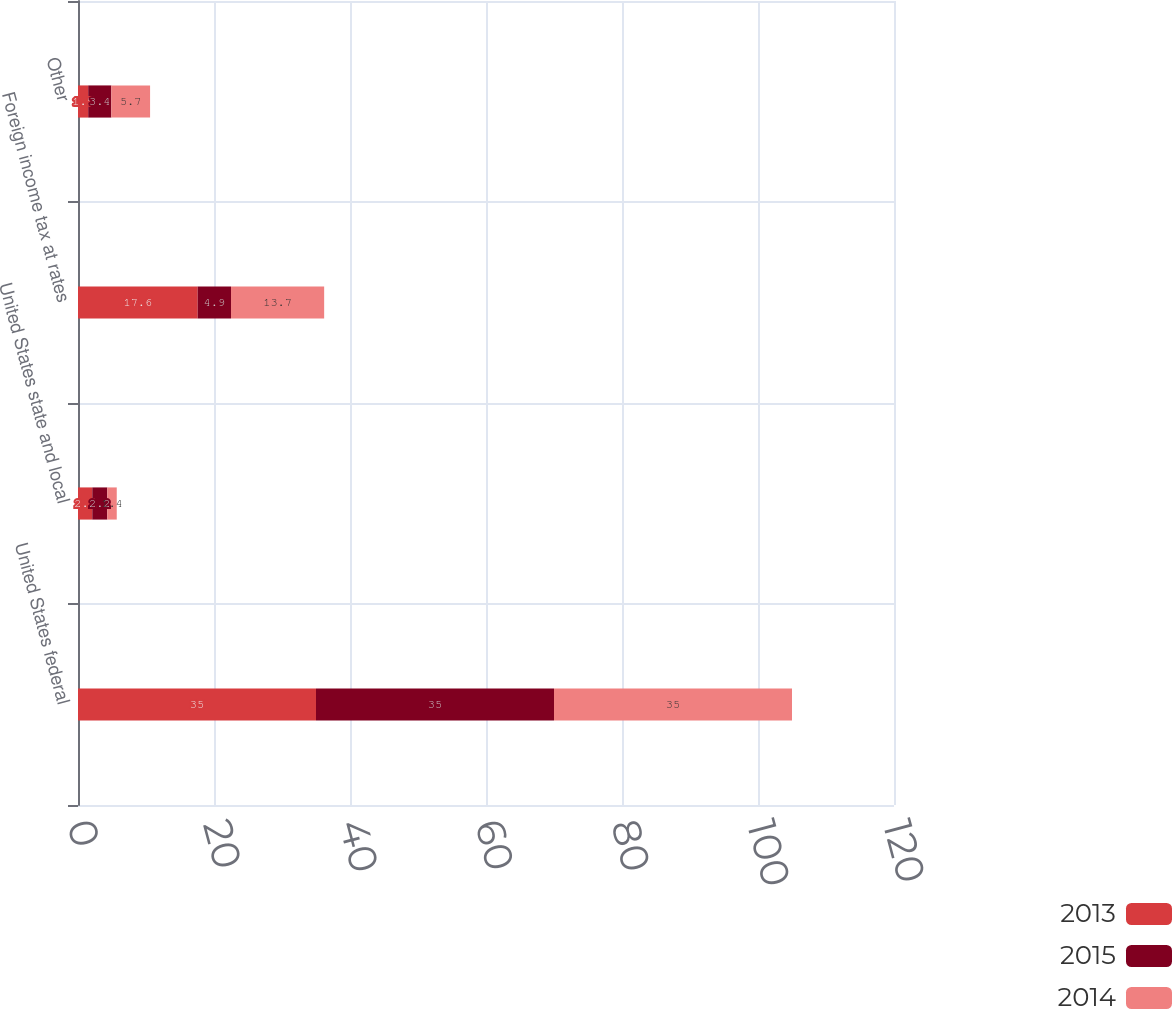Convert chart to OTSL. <chart><loc_0><loc_0><loc_500><loc_500><stacked_bar_chart><ecel><fcel>United States federal<fcel>United States state and local<fcel>Foreign income tax at rates<fcel>Other<nl><fcel>2013<fcel>35<fcel>2.1<fcel>17.6<fcel>1.5<nl><fcel>2015<fcel>35<fcel>2.2<fcel>4.9<fcel>3.4<nl><fcel>2014<fcel>35<fcel>1.4<fcel>13.7<fcel>5.7<nl></chart> 